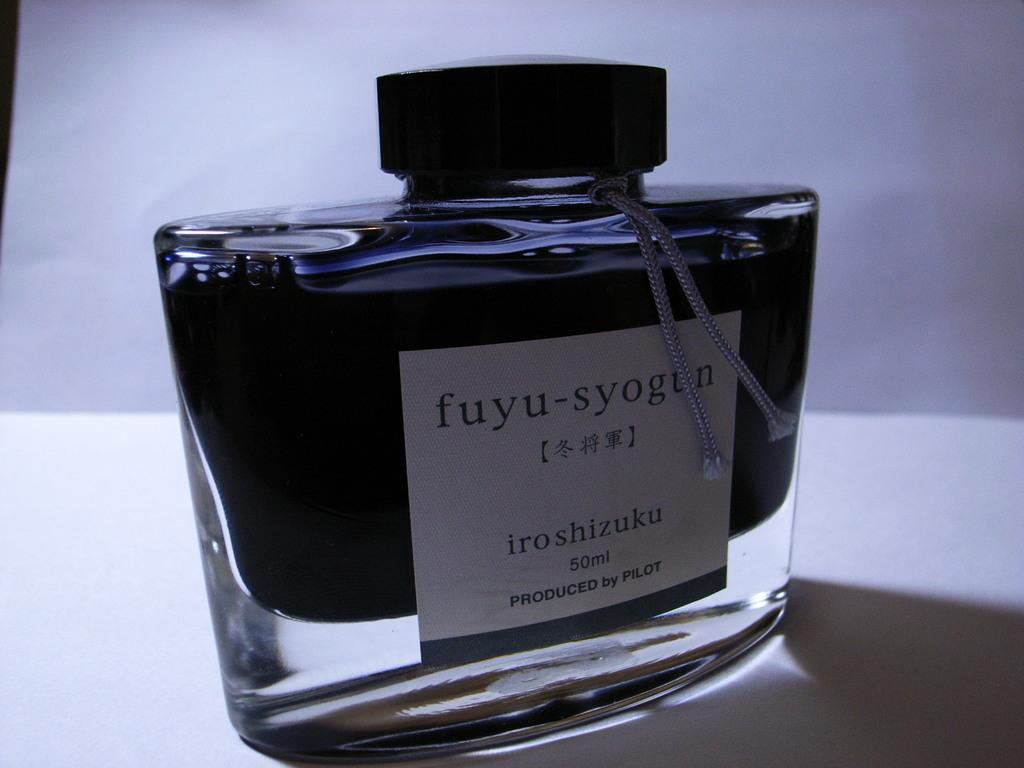<image>
Describe the image concisely. A blue bottle of fuyu soygun perfum by iroshizuku. 